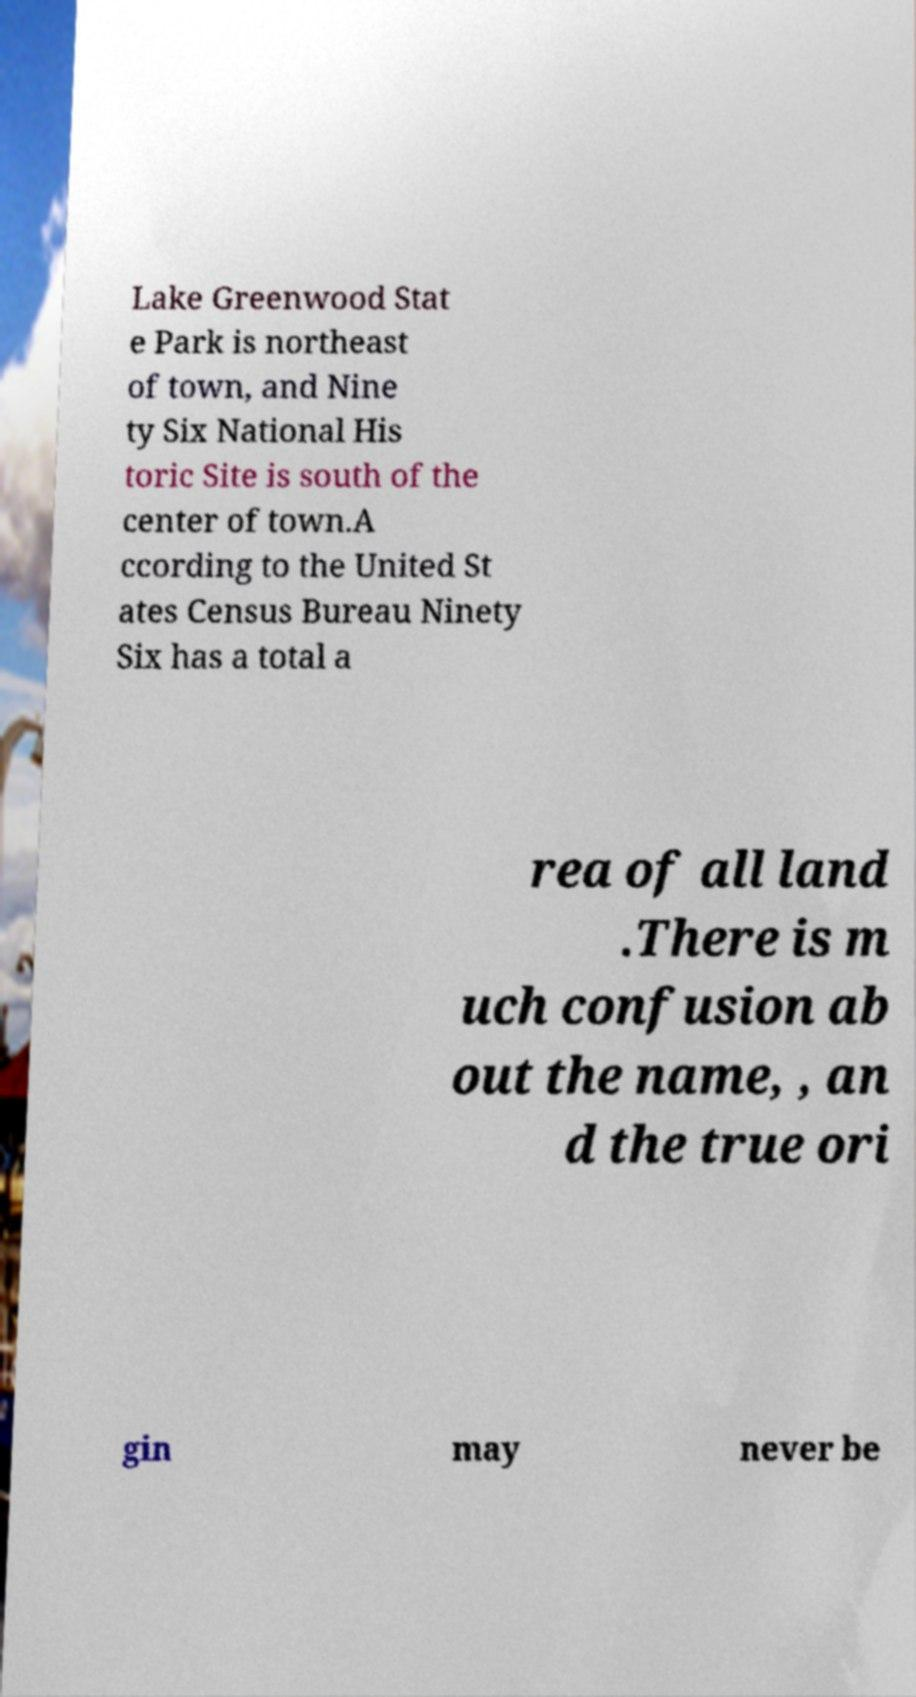For documentation purposes, I need the text within this image transcribed. Could you provide that? Lake Greenwood Stat e Park is northeast of town, and Nine ty Six National His toric Site is south of the center of town.A ccording to the United St ates Census Bureau Ninety Six has a total a rea of all land .There is m uch confusion ab out the name, , an d the true ori gin may never be 